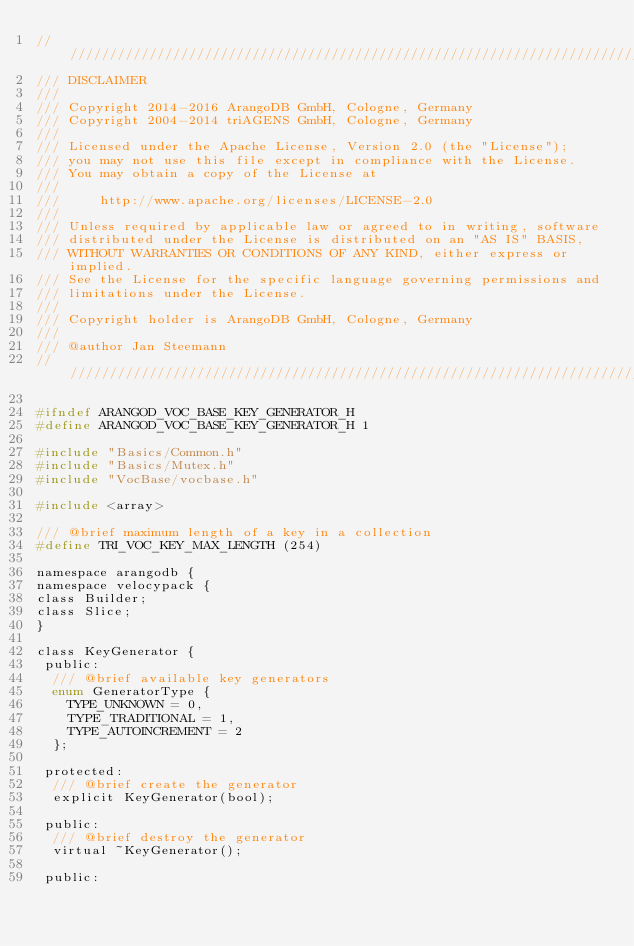Convert code to text. <code><loc_0><loc_0><loc_500><loc_500><_C_>////////////////////////////////////////////////////////////////////////////////
/// DISCLAIMER
///
/// Copyright 2014-2016 ArangoDB GmbH, Cologne, Germany
/// Copyright 2004-2014 triAGENS GmbH, Cologne, Germany
///
/// Licensed under the Apache License, Version 2.0 (the "License");
/// you may not use this file except in compliance with the License.
/// You may obtain a copy of the License at
///
///     http://www.apache.org/licenses/LICENSE-2.0
///
/// Unless required by applicable law or agreed to in writing, software
/// distributed under the License is distributed on an "AS IS" BASIS,
/// WITHOUT WARRANTIES OR CONDITIONS OF ANY KIND, either express or implied.
/// See the License for the specific language governing permissions and
/// limitations under the License.
///
/// Copyright holder is ArangoDB GmbH, Cologne, Germany
///
/// @author Jan Steemann
////////////////////////////////////////////////////////////////////////////////

#ifndef ARANGOD_VOC_BASE_KEY_GENERATOR_H
#define ARANGOD_VOC_BASE_KEY_GENERATOR_H 1

#include "Basics/Common.h"
#include "Basics/Mutex.h"
#include "VocBase/vocbase.h"

#include <array>

/// @brief maximum length of a key in a collection
#define TRI_VOC_KEY_MAX_LENGTH (254)

namespace arangodb {
namespace velocypack {
class Builder;
class Slice;
}

class KeyGenerator {
 public:
  /// @brief available key generators
  enum GeneratorType {
    TYPE_UNKNOWN = 0,
    TYPE_TRADITIONAL = 1,
    TYPE_AUTOINCREMENT = 2
  };

 protected:
  /// @brief create the generator
  explicit KeyGenerator(bool);

 public:
  /// @brief destroy the generator
  virtual ~KeyGenerator();

 public:</code> 